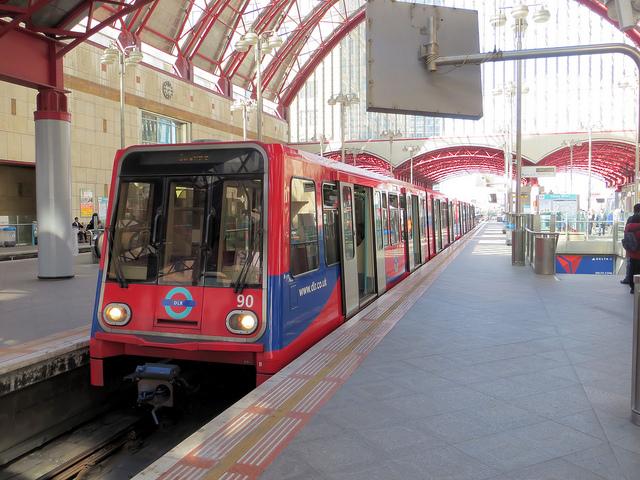Is this an older transportation system?
Write a very short answer. No. Is this a bus station?
Give a very brief answer. No. Can you see the bus driver?
Be succinct. No. Is the train loading people?
Give a very brief answer. No. Is this a train station?
Short answer required. Yes. Can more than one train fit on a track?
Concise answer only. No. What is the bus number?
Quick response, please. 90. 